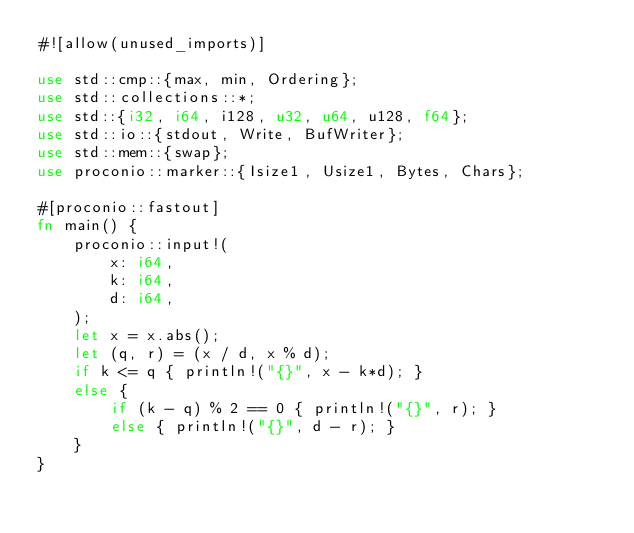Convert code to text. <code><loc_0><loc_0><loc_500><loc_500><_Rust_>#![allow(unused_imports)]

use std::cmp::{max, min, Ordering};
use std::collections::*;
use std::{i32, i64, i128, u32, u64, u128, f64};
use std::io::{stdout, Write, BufWriter};
use std::mem::{swap};
use proconio::marker::{Isize1, Usize1, Bytes, Chars};

#[proconio::fastout]
fn main() {
    proconio::input!(
        x: i64,
        k: i64,
        d: i64,
    );
    let x = x.abs();
    let (q, r) = (x / d, x % d);
    if k <= q { println!("{}", x - k*d); }
    else {
        if (k - q) % 2 == 0 { println!("{}", r); }
        else { println!("{}", d - r); }
    }
}
</code> 